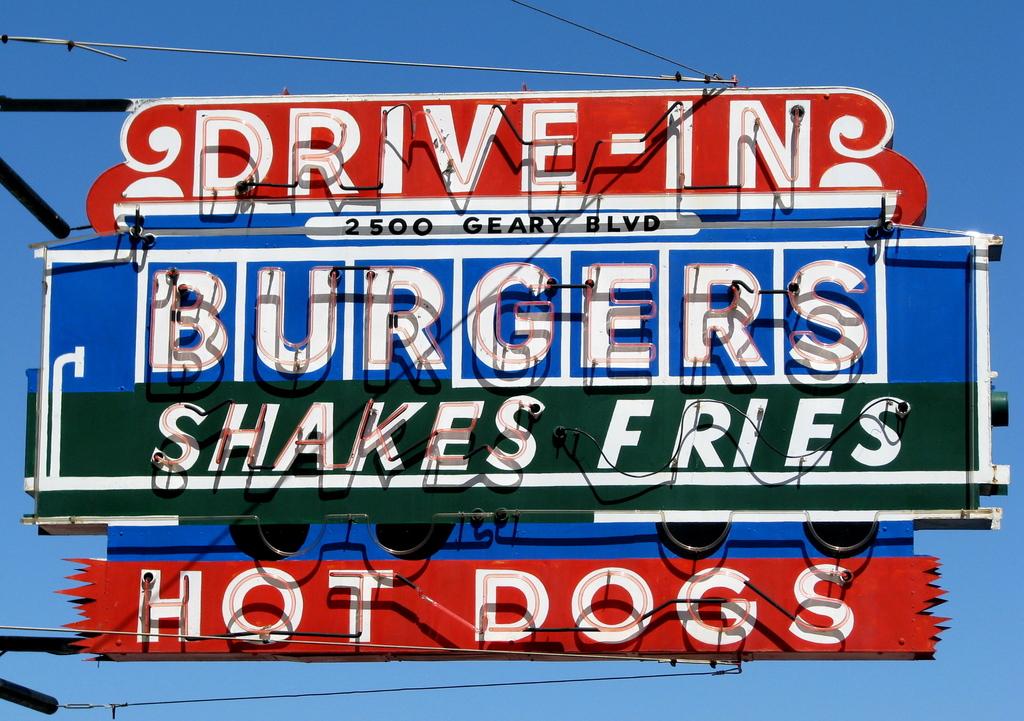What kinds of foods does the diner serve?
Your answer should be very brief. Burgers, shakes, fries, and hot dogs. Do they serve hot dogs here?
Give a very brief answer. Yes. 